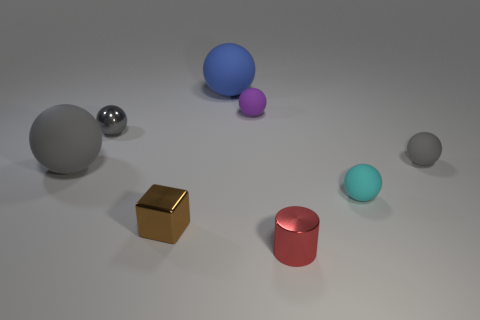Subtract all gray balls. How many were subtracted if there are1gray balls left? 2 Subtract all small gray rubber spheres. How many spheres are left? 5 Subtract all gray spheres. How many spheres are left? 3 Add 1 purple objects. How many objects exist? 9 Subtract all blocks. How many objects are left? 7 Add 1 tiny red metallic cylinders. How many tiny red metallic cylinders are left? 2 Add 7 tiny yellow shiny cylinders. How many tiny yellow shiny cylinders exist? 7 Subtract 0 green spheres. How many objects are left? 8 Subtract 6 spheres. How many spheres are left? 0 Subtract all cyan spheres. Subtract all gray cylinders. How many spheres are left? 5 